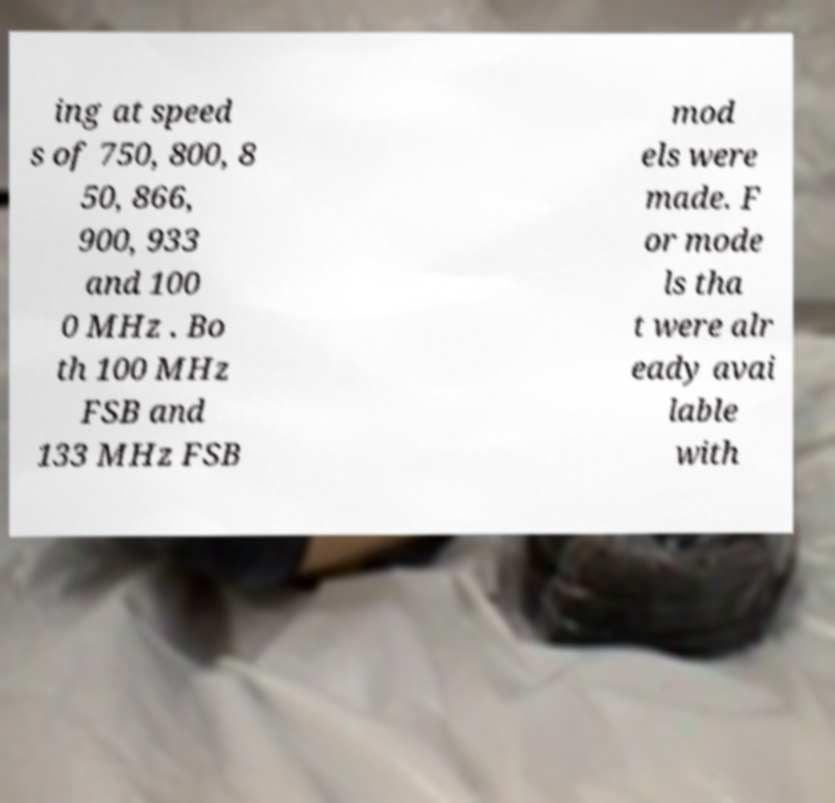Please identify and transcribe the text found in this image. ing at speed s of 750, 800, 8 50, 866, 900, 933 and 100 0 MHz . Bo th 100 MHz FSB and 133 MHz FSB mod els were made. F or mode ls tha t were alr eady avai lable with 